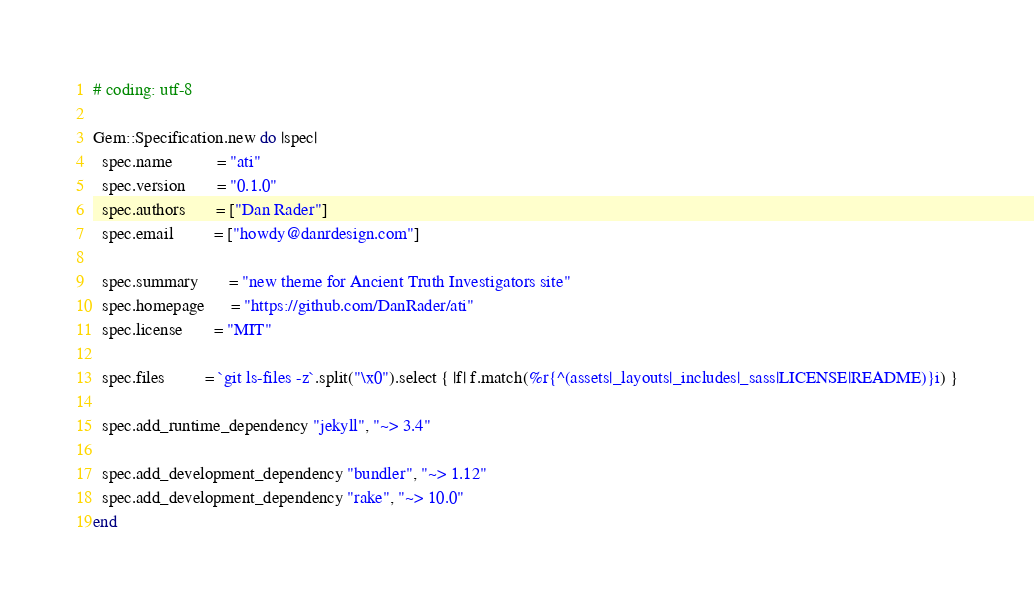Convert code to text. <code><loc_0><loc_0><loc_500><loc_500><_Ruby_># coding: utf-8

Gem::Specification.new do |spec|
  spec.name          = "ati"
  spec.version       = "0.1.0"
  spec.authors       = ["Dan Rader"]
  spec.email         = ["howdy@danrdesign.com"]

  spec.summary       = "new theme for Ancient Truth Investigators site"
  spec.homepage      = "https://github.com/DanRader/ati"
  spec.license       = "MIT"

  spec.files         = `git ls-files -z`.split("\x0").select { |f| f.match(%r{^(assets|_layouts|_includes|_sass|LICENSE|README)}i) }

  spec.add_runtime_dependency "jekyll", "~> 3.4"

  spec.add_development_dependency "bundler", "~> 1.12"
  spec.add_development_dependency "rake", "~> 10.0"
end
</code> 